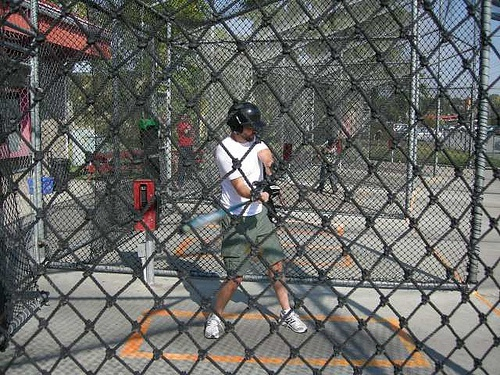Describe the objects in this image and their specific colors. I can see people in black, gray, white, and darkgray tones, people in black, gray, maroon, and brown tones, baseball bat in black, darkgray, gray, and blue tones, people in black, gray, and darkgray tones, and car in black, darkgray, gray, and lightgray tones in this image. 